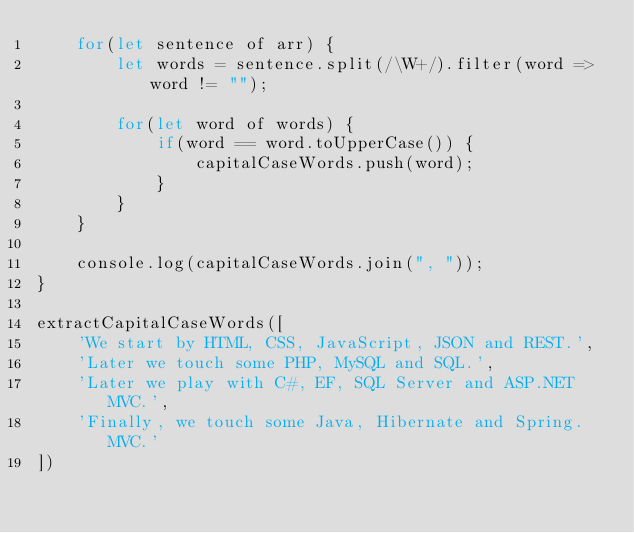<code> <loc_0><loc_0><loc_500><loc_500><_JavaScript_>    for(let sentence of arr) {
        let words = sentence.split(/\W+/).filter(word => word != "");

        for(let word of words) {
            if(word == word.toUpperCase()) {
                capitalCaseWords.push(word);
            }
        }
    }

    console.log(capitalCaseWords.join(", "));
}

extractCapitalCaseWords([
    'We start by HTML, CSS, JavaScript, JSON and REST.',
    'Later we touch some PHP, MySQL and SQL.',
    'Later we play with C#, EF, SQL Server and ASP.NET MVC.',
    'Finally, we touch some Java, Hibernate and Spring.MVC.'
])</code> 